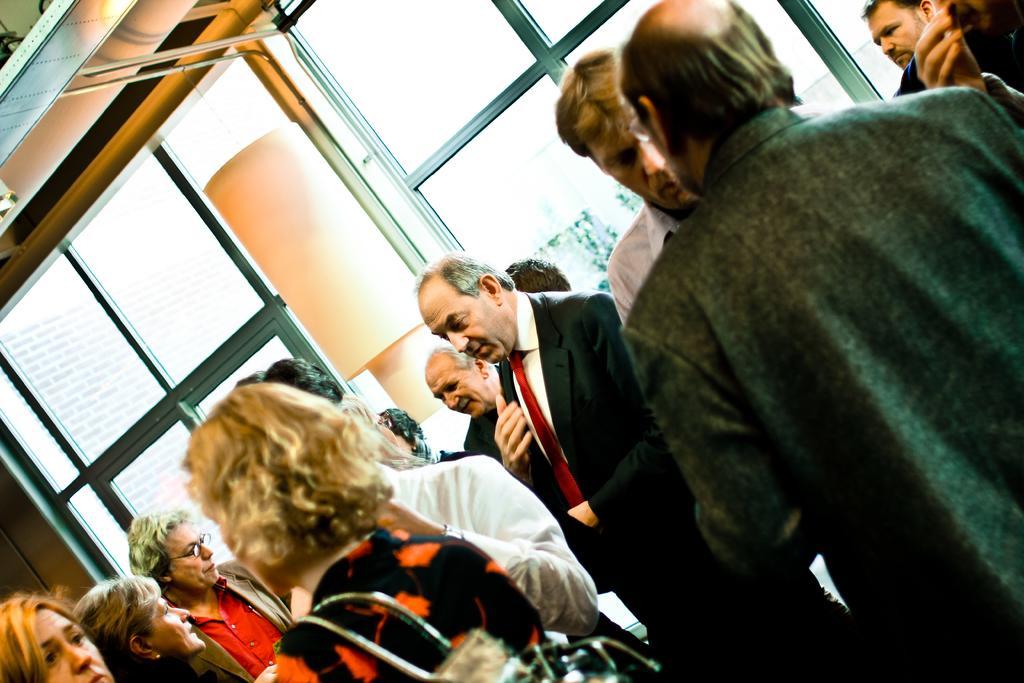How would you summarize this image in a sentence or two? In this picture I can see people standing. I can see glass windows in the background. 